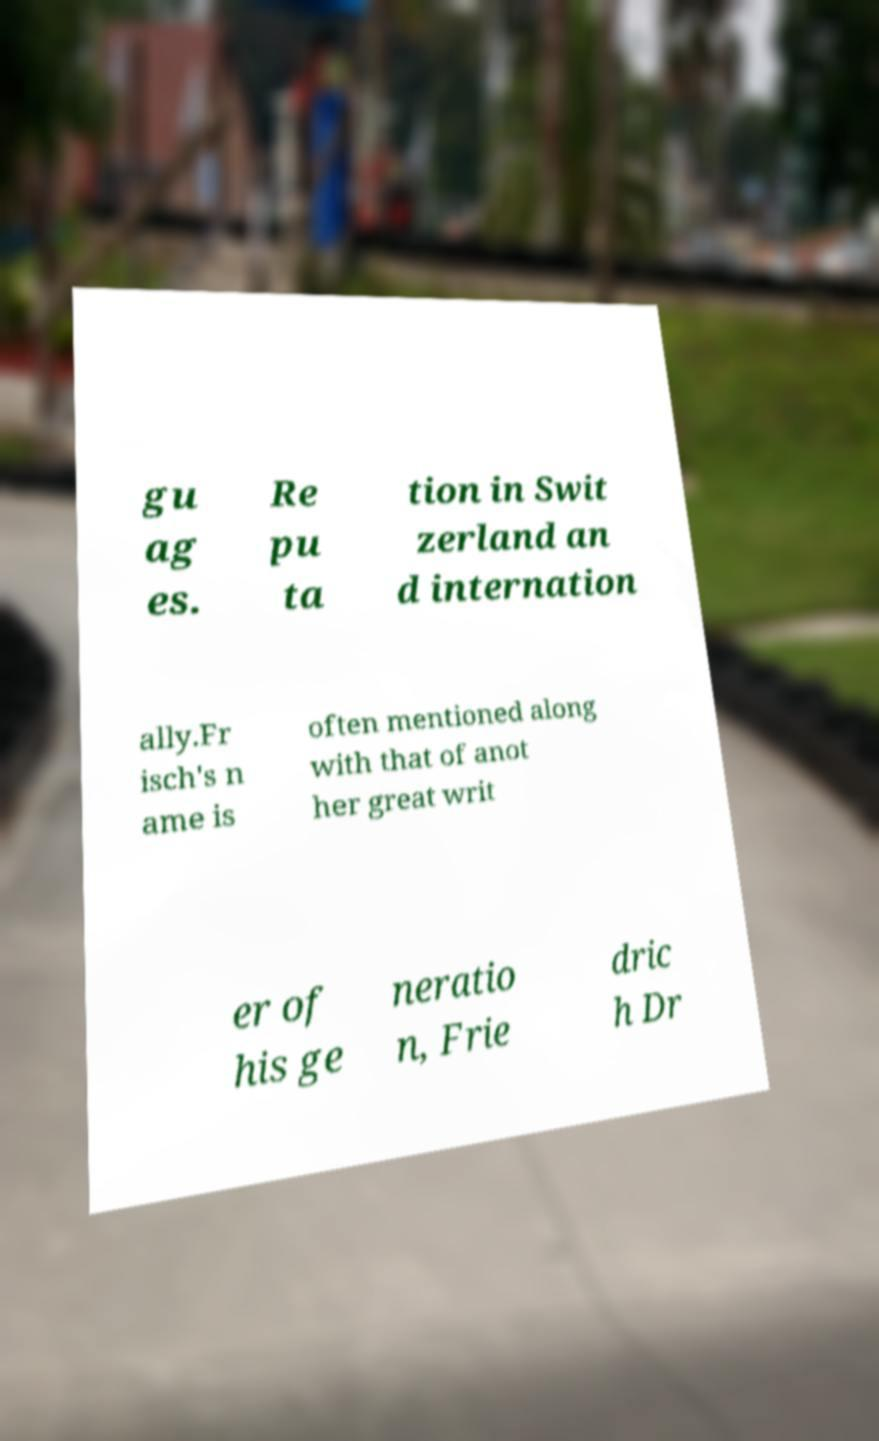Could you assist in decoding the text presented in this image and type it out clearly? gu ag es. Re pu ta tion in Swit zerland an d internation ally.Fr isch's n ame is often mentioned along with that of anot her great writ er of his ge neratio n, Frie dric h Dr 